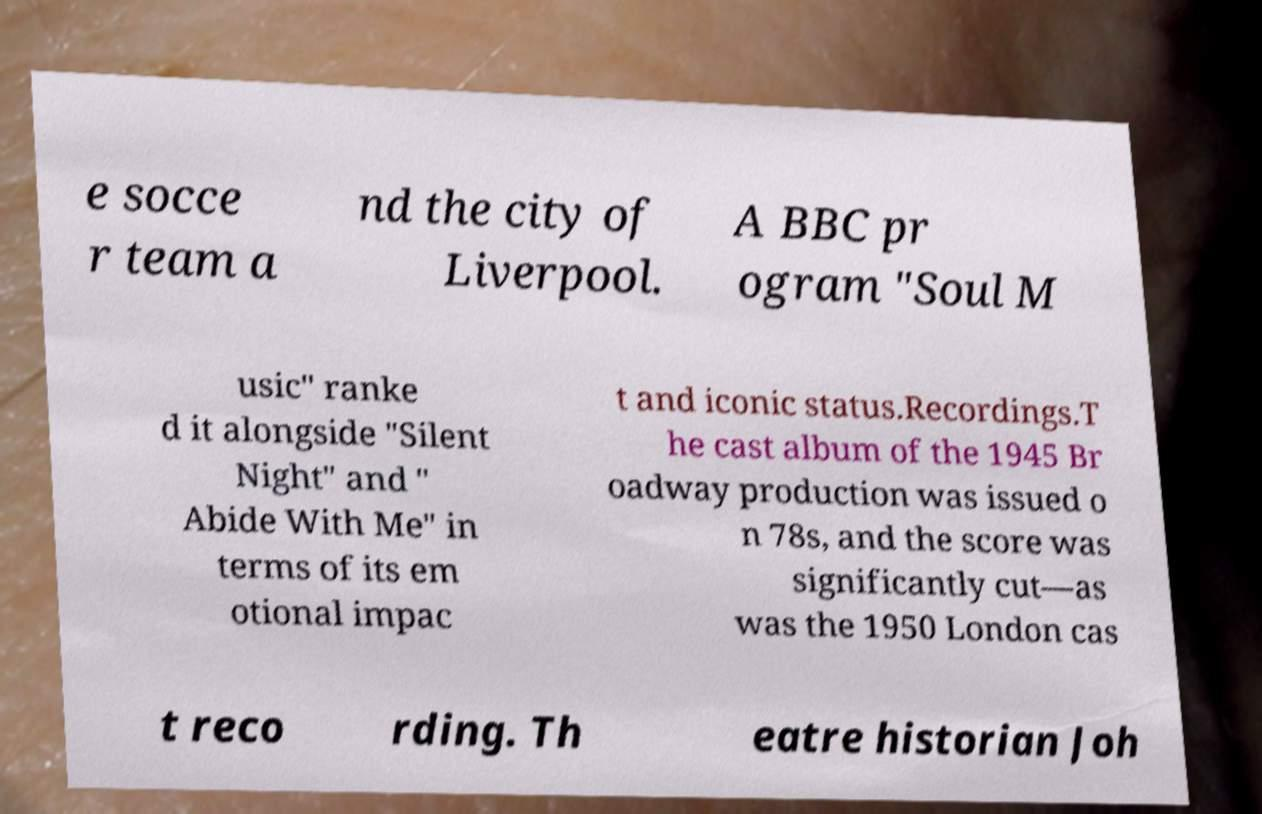Can you accurately transcribe the text from the provided image for me? e socce r team a nd the city of Liverpool. A BBC pr ogram "Soul M usic" ranke d it alongside "Silent Night" and " Abide With Me" in terms of its em otional impac t and iconic status.Recordings.T he cast album of the 1945 Br oadway production was issued o n 78s, and the score was significantly cut—as was the 1950 London cas t reco rding. Th eatre historian Joh 